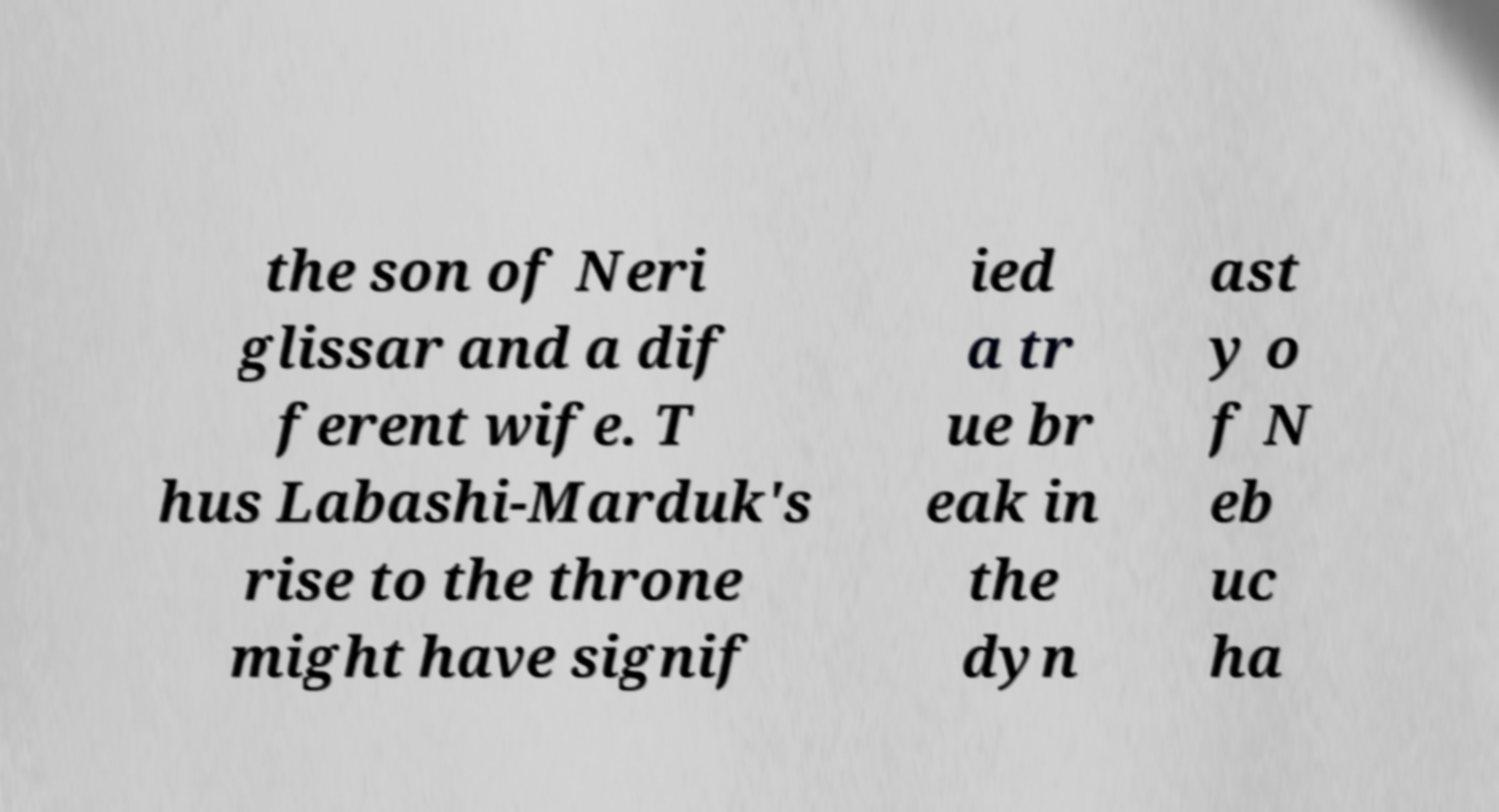Can you accurately transcribe the text from the provided image for me? the son of Neri glissar and a dif ferent wife. T hus Labashi-Marduk's rise to the throne might have signif ied a tr ue br eak in the dyn ast y o f N eb uc ha 